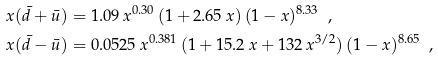<formula> <loc_0><loc_0><loc_500><loc_500>x ( \bar { d } + \bar { u } ) & = 1 . 0 9 \, x ^ { 0 . 3 0 } \, ( 1 + 2 . 6 5 \, x ) \, ( 1 - x ) ^ { 8 . 3 3 } \ \ , \\ x ( \bar { d } - \bar { u } ) & = 0 . 0 5 2 5 \, x ^ { 0 . 3 8 1 } \, ( 1 + 1 5 . 2 \, x + 1 3 2 \, x ^ { 3 / 2 } ) \, ( 1 - x ) ^ { 8 . 6 5 } \ \ ,</formula> 